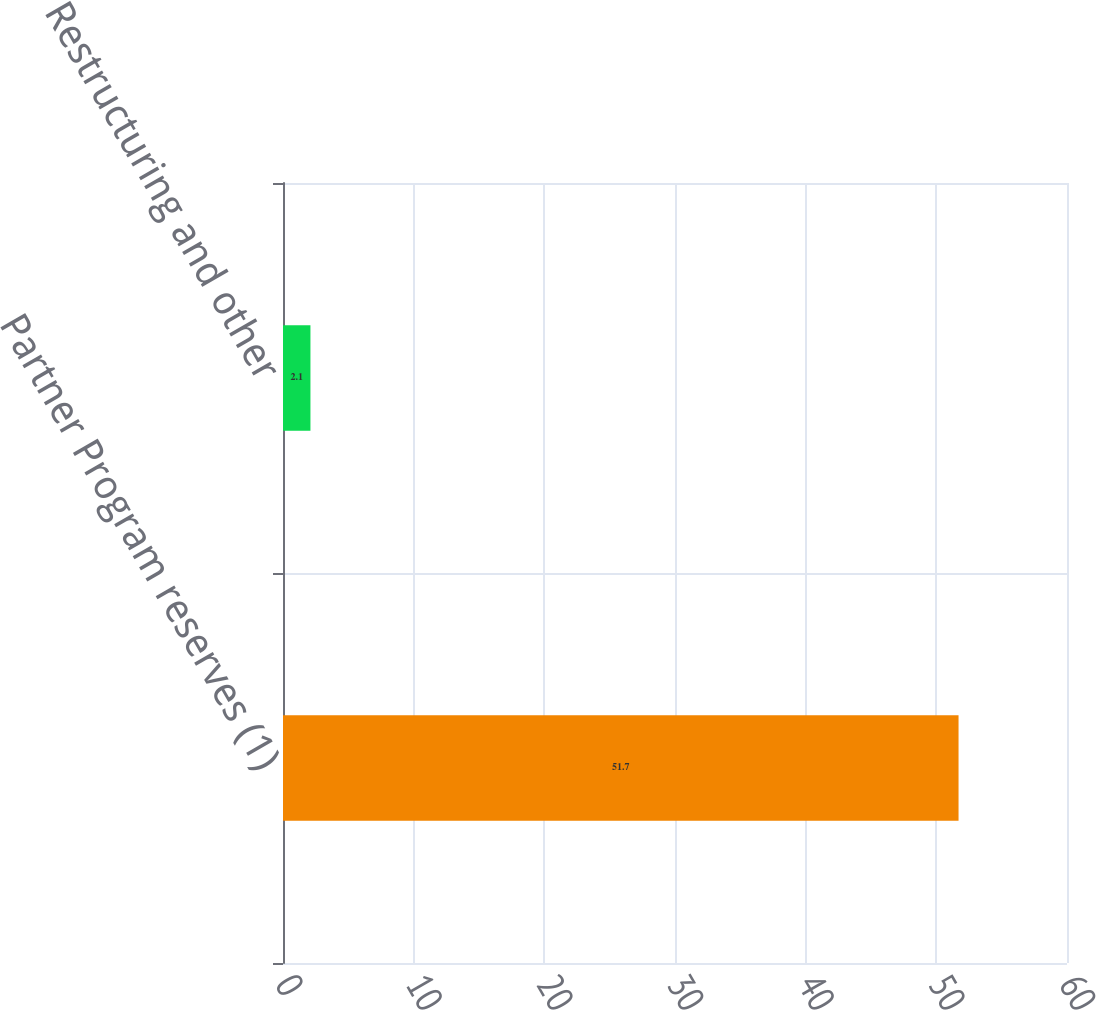Convert chart. <chart><loc_0><loc_0><loc_500><loc_500><bar_chart><fcel>Partner Program reserves (1)<fcel>Restructuring and other<nl><fcel>51.7<fcel>2.1<nl></chart> 